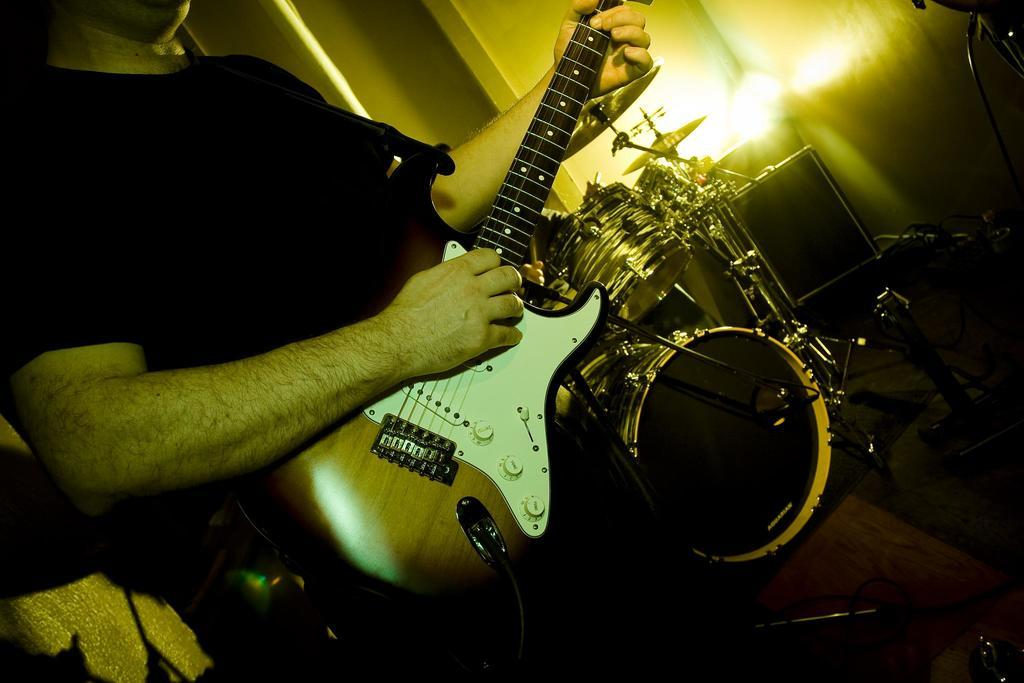What is the man in the image doing? The man in the image is playing a guitar. What other musical instrument can be seen in the image? There are drums in the image. Is there any source of illumination in the image? Yes, there is a light in the image. What is the man wearing in the image? The man is wearing a black t-shirt. How many chickens are present in the image? There are no chickens present in the image. What type of cave can be seen in the background of the image? There is no cave present in the image. 